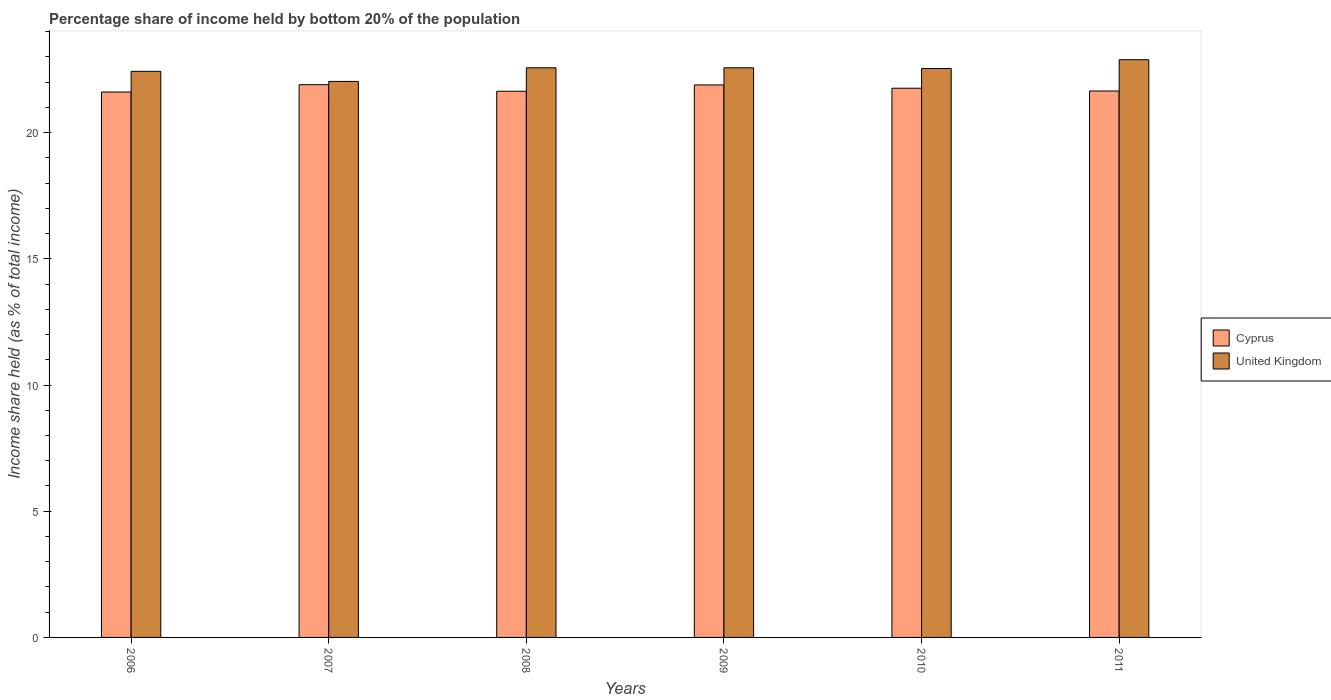How many different coloured bars are there?
Your answer should be compact. 2. How many groups of bars are there?
Your answer should be very brief. 6. Are the number of bars per tick equal to the number of legend labels?
Your answer should be compact. Yes. How many bars are there on the 6th tick from the left?
Provide a short and direct response. 2. How many bars are there on the 1st tick from the right?
Provide a succinct answer. 2. In how many cases, is the number of bars for a given year not equal to the number of legend labels?
Make the answer very short. 0. What is the share of income held by bottom 20% of the population in Cyprus in 2006?
Give a very brief answer. 21.61. Across all years, what is the maximum share of income held by bottom 20% of the population in Cyprus?
Your answer should be compact. 21.9. Across all years, what is the minimum share of income held by bottom 20% of the population in United Kingdom?
Offer a very short reply. 22.03. In which year was the share of income held by bottom 20% of the population in United Kingdom maximum?
Your answer should be compact. 2011. What is the total share of income held by bottom 20% of the population in Cyprus in the graph?
Make the answer very short. 130.45. What is the difference between the share of income held by bottom 20% of the population in Cyprus in 2008 and that in 2009?
Your response must be concise. -0.25. What is the difference between the share of income held by bottom 20% of the population in United Kingdom in 2011 and the share of income held by bottom 20% of the population in Cyprus in 2009?
Give a very brief answer. 1. What is the average share of income held by bottom 20% of the population in Cyprus per year?
Keep it short and to the point. 21.74. In the year 2011, what is the difference between the share of income held by bottom 20% of the population in Cyprus and share of income held by bottom 20% of the population in United Kingdom?
Your answer should be compact. -1.24. In how many years, is the share of income held by bottom 20% of the population in Cyprus greater than 6 %?
Keep it short and to the point. 6. What is the ratio of the share of income held by bottom 20% of the population in United Kingdom in 2010 to that in 2011?
Keep it short and to the point. 0.98. What is the difference between the highest and the second highest share of income held by bottom 20% of the population in United Kingdom?
Your response must be concise. 0.32. What is the difference between the highest and the lowest share of income held by bottom 20% of the population in Cyprus?
Provide a succinct answer. 0.29. Is the sum of the share of income held by bottom 20% of the population in United Kingdom in 2008 and 2011 greater than the maximum share of income held by bottom 20% of the population in Cyprus across all years?
Keep it short and to the point. Yes. What does the 1st bar from the left in 2011 represents?
Your answer should be compact. Cyprus. What does the 2nd bar from the right in 2006 represents?
Give a very brief answer. Cyprus. Are all the bars in the graph horizontal?
Offer a very short reply. No. How many years are there in the graph?
Your answer should be very brief. 6. What is the difference between two consecutive major ticks on the Y-axis?
Make the answer very short. 5. Where does the legend appear in the graph?
Provide a succinct answer. Center right. How many legend labels are there?
Ensure brevity in your answer.  2. What is the title of the graph?
Give a very brief answer. Percentage share of income held by bottom 20% of the population. What is the label or title of the X-axis?
Your answer should be very brief. Years. What is the label or title of the Y-axis?
Provide a short and direct response. Income share held (as % of total income). What is the Income share held (as % of total income) of Cyprus in 2006?
Give a very brief answer. 21.61. What is the Income share held (as % of total income) of United Kingdom in 2006?
Make the answer very short. 22.43. What is the Income share held (as % of total income) of Cyprus in 2007?
Your answer should be very brief. 21.9. What is the Income share held (as % of total income) in United Kingdom in 2007?
Provide a succinct answer. 22.03. What is the Income share held (as % of total income) in Cyprus in 2008?
Offer a terse response. 21.64. What is the Income share held (as % of total income) in United Kingdom in 2008?
Your answer should be very brief. 22.57. What is the Income share held (as % of total income) in Cyprus in 2009?
Offer a very short reply. 21.89. What is the Income share held (as % of total income) in United Kingdom in 2009?
Provide a succinct answer. 22.57. What is the Income share held (as % of total income) in Cyprus in 2010?
Give a very brief answer. 21.76. What is the Income share held (as % of total income) in United Kingdom in 2010?
Your answer should be compact. 22.54. What is the Income share held (as % of total income) of Cyprus in 2011?
Your response must be concise. 21.65. What is the Income share held (as % of total income) in United Kingdom in 2011?
Your response must be concise. 22.89. Across all years, what is the maximum Income share held (as % of total income) in Cyprus?
Your answer should be very brief. 21.9. Across all years, what is the maximum Income share held (as % of total income) of United Kingdom?
Your answer should be very brief. 22.89. Across all years, what is the minimum Income share held (as % of total income) in Cyprus?
Provide a short and direct response. 21.61. Across all years, what is the minimum Income share held (as % of total income) in United Kingdom?
Your answer should be compact. 22.03. What is the total Income share held (as % of total income) in Cyprus in the graph?
Provide a succinct answer. 130.45. What is the total Income share held (as % of total income) in United Kingdom in the graph?
Give a very brief answer. 135.03. What is the difference between the Income share held (as % of total income) in Cyprus in 2006 and that in 2007?
Provide a succinct answer. -0.29. What is the difference between the Income share held (as % of total income) in Cyprus in 2006 and that in 2008?
Provide a succinct answer. -0.03. What is the difference between the Income share held (as % of total income) in United Kingdom in 2006 and that in 2008?
Give a very brief answer. -0.14. What is the difference between the Income share held (as % of total income) in Cyprus in 2006 and that in 2009?
Make the answer very short. -0.28. What is the difference between the Income share held (as % of total income) of United Kingdom in 2006 and that in 2009?
Provide a short and direct response. -0.14. What is the difference between the Income share held (as % of total income) in United Kingdom in 2006 and that in 2010?
Provide a short and direct response. -0.11. What is the difference between the Income share held (as % of total income) in Cyprus in 2006 and that in 2011?
Make the answer very short. -0.04. What is the difference between the Income share held (as % of total income) of United Kingdom in 2006 and that in 2011?
Your response must be concise. -0.46. What is the difference between the Income share held (as % of total income) of Cyprus in 2007 and that in 2008?
Ensure brevity in your answer.  0.26. What is the difference between the Income share held (as % of total income) of United Kingdom in 2007 and that in 2008?
Your answer should be very brief. -0.54. What is the difference between the Income share held (as % of total income) of United Kingdom in 2007 and that in 2009?
Your answer should be very brief. -0.54. What is the difference between the Income share held (as % of total income) of Cyprus in 2007 and that in 2010?
Give a very brief answer. 0.14. What is the difference between the Income share held (as % of total income) of United Kingdom in 2007 and that in 2010?
Your answer should be compact. -0.51. What is the difference between the Income share held (as % of total income) of United Kingdom in 2007 and that in 2011?
Keep it short and to the point. -0.86. What is the difference between the Income share held (as % of total income) in Cyprus in 2008 and that in 2009?
Keep it short and to the point. -0.25. What is the difference between the Income share held (as % of total income) of Cyprus in 2008 and that in 2010?
Your answer should be very brief. -0.12. What is the difference between the Income share held (as % of total income) of United Kingdom in 2008 and that in 2010?
Ensure brevity in your answer.  0.03. What is the difference between the Income share held (as % of total income) of Cyprus in 2008 and that in 2011?
Provide a succinct answer. -0.01. What is the difference between the Income share held (as % of total income) in United Kingdom in 2008 and that in 2011?
Offer a very short reply. -0.32. What is the difference between the Income share held (as % of total income) in Cyprus in 2009 and that in 2010?
Keep it short and to the point. 0.13. What is the difference between the Income share held (as % of total income) in Cyprus in 2009 and that in 2011?
Offer a very short reply. 0.24. What is the difference between the Income share held (as % of total income) of United Kingdom in 2009 and that in 2011?
Ensure brevity in your answer.  -0.32. What is the difference between the Income share held (as % of total income) of Cyprus in 2010 and that in 2011?
Your answer should be compact. 0.11. What is the difference between the Income share held (as % of total income) in United Kingdom in 2010 and that in 2011?
Your response must be concise. -0.35. What is the difference between the Income share held (as % of total income) in Cyprus in 2006 and the Income share held (as % of total income) in United Kingdom in 2007?
Your answer should be very brief. -0.42. What is the difference between the Income share held (as % of total income) of Cyprus in 2006 and the Income share held (as % of total income) of United Kingdom in 2008?
Offer a very short reply. -0.96. What is the difference between the Income share held (as % of total income) of Cyprus in 2006 and the Income share held (as % of total income) of United Kingdom in 2009?
Give a very brief answer. -0.96. What is the difference between the Income share held (as % of total income) in Cyprus in 2006 and the Income share held (as % of total income) in United Kingdom in 2010?
Make the answer very short. -0.93. What is the difference between the Income share held (as % of total income) of Cyprus in 2006 and the Income share held (as % of total income) of United Kingdom in 2011?
Give a very brief answer. -1.28. What is the difference between the Income share held (as % of total income) of Cyprus in 2007 and the Income share held (as % of total income) of United Kingdom in 2008?
Provide a succinct answer. -0.67. What is the difference between the Income share held (as % of total income) of Cyprus in 2007 and the Income share held (as % of total income) of United Kingdom in 2009?
Your answer should be very brief. -0.67. What is the difference between the Income share held (as % of total income) of Cyprus in 2007 and the Income share held (as % of total income) of United Kingdom in 2010?
Your answer should be compact. -0.64. What is the difference between the Income share held (as % of total income) of Cyprus in 2007 and the Income share held (as % of total income) of United Kingdom in 2011?
Ensure brevity in your answer.  -0.99. What is the difference between the Income share held (as % of total income) of Cyprus in 2008 and the Income share held (as % of total income) of United Kingdom in 2009?
Offer a terse response. -0.93. What is the difference between the Income share held (as % of total income) in Cyprus in 2008 and the Income share held (as % of total income) in United Kingdom in 2011?
Ensure brevity in your answer.  -1.25. What is the difference between the Income share held (as % of total income) of Cyprus in 2009 and the Income share held (as % of total income) of United Kingdom in 2010?
Your answer should be compact. -0.65. What is the difference between the Income share held (as % of total income) of Cyprus in 2010 and the Income share held (as % of total income) of United Kingdom in 2011?
Provide a short and direct response. -1.13. What is the average Income share held (as % of total income) of Cyprus per year?
Make the answer very short. 21.74. What is the average Income share held (as % of total income) in United Kingdom per year?
Ensure brevity in your answer.  22.5. In the year 2006, what is the difference between the Income share held (as % of total income) of Cyprus and Income share held (as % of total income) of United Kingdom?
Ensure brevity in your answer.  -0.82. In the year 2007, what is the difference between the Income share held (as % of total income) in Cyprus and Income share held (as % of total income) in United Kingdom?
Provide a short and direct response. -0.13. In the year 2008, what is the difference between the Income share held (as % of total income) in Cyprus and Income share held (as % of total income) in United Kingdom?
Ensure brevity in your answer.  -0.93. In the year 2009, what is the difference between the Income share held (as % of total income) of Cyprus and Income share held (as % of total income) of United Kingdom?
Ensure brevity in your answer.  -0.68. In the year 2010, what is the difference between the Income share held (as % of total income) of Cyprus and Income share held (as % of total income) of United Kingdom?
Give a very brief answer. -0.78. In the year 2011, what is the difference between the Income share held (as % of total income) in Cyprus and Income share held (as % of total income) in United Kingdom?
Give a very brief answer. -1.24. What is the ratio of the Income share held (as % of total income) of United Kingdom in 2006 to that in 2007?
Offer a very short reply. 1.02. What is the ratio of the Income share held (as % of total income) in United Kingdom in 2006 to that in 2008?
Keep it short and to the point. 0.99. What is the ratio of the Income share held (as % of total income) of Cyprus in 2006 to that in 2009?
Your answer should be compact. 0.99. What is the ratio of the Income share held (as % of total income) of United Kingdom in 2006 to that in 2011?
Provide a succinct answer. 0.98. What is the ratio of the Income share held (as % of total income) in United Kingdom in 2007 to that in 2008?
Give a very brief answer. 0.98. What is the ratio of the Income share held (as % of total income) of Cyprus in 2007 to that in 2009?
Keep it short and to the point. 1. What is the ratio of the Income share held (as % of total income) of United Kingdom in 2007 to that in 2009?
Your response must be concise. 0.98. What is the ratio of the Income share held (as % of total income) in Cyprus in 2007 to that in 2010?
Provide a short and direct response. 1.01. What is the ratio of the Income share held (as % of total income) in United Kingdom in 2007 to that in 2010?
Make the answer very short. 0.98. What is the ratio of the Income share held (as % of total income) of Cyprus in 2007 to that in 2011?
Keep it short and to the point. 1.01. What is the ratio of the Income share held (as % of total income) of United Kingdom in 2007 to that in 2011?
Keep it short and to the point. 0.96. What is the ratio of the Income share held (as % of total income) in Cyprus in 2008 to that in 2009?
Provide a succinct answer. 0.99. What is the ratio of the Income share held (as % of total income) in United Kingdom in 2008 to that in 2009?
Your response must be concise. 1. What is the ratio of the Income share held (as % of total income) in Cyprus in 2008 to that in 2010?
Your answer should be very brief. 0.99. What is the ratio of the Income share held (as % of total income) of Cyprus in 2009 to that in 2010?
Ensure brevity in your answer.  1.01. What is the ratio of the Income share held (as % of total income) in Cyprus in 2009 to that in 2011?
Offer a terse response. 1.01. What is the ratio of the Income share held (as % of total income) in United Kingdom in 2009 to that in 2011?
Provide a short and direct response. 0.99. What is the ratio of the Income share held (as % of total income) of United Kingdom in 2010 to that in 2011?
Offer a very short reply. 0.98. What is the difference between the highest and the second highest Income share held (as % of total income) of United Kingdom?
Keep it short and to the point. 0.32. What is the difference between the highest and the lowest Income share held (as % of total income) of Cyprus?
Provide a short and direct response. 0.29. What is the difference between the highest and the lowest Income share held (as % of total income) of United Kingdom?
Ensure brevity in your answer.  0.86. 